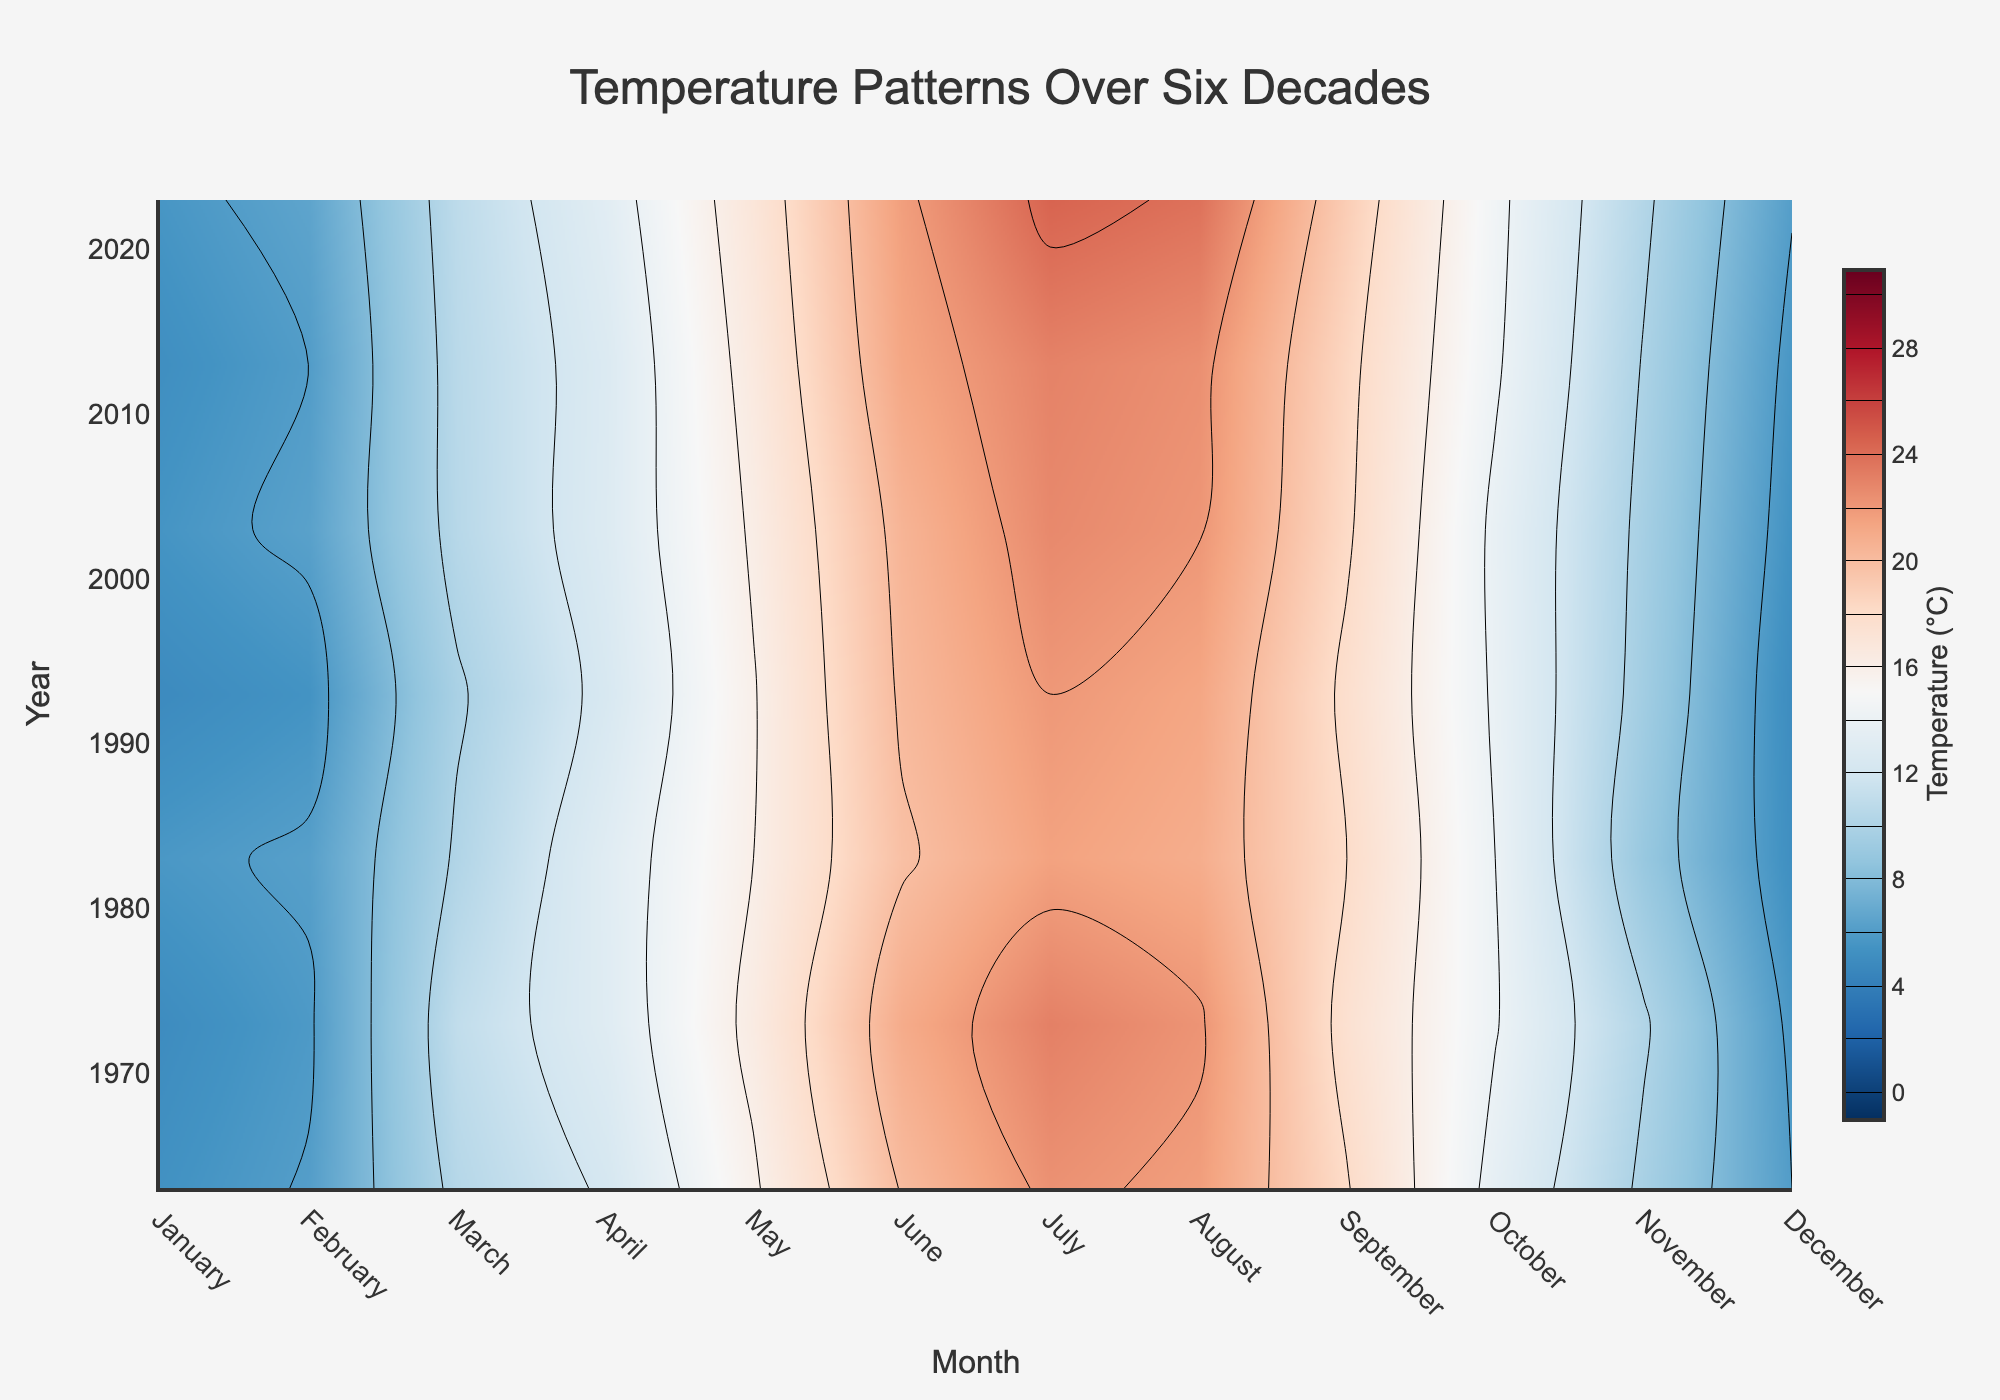What is the overall trend in July temperatures from 1963 to 2023? To answer this, we need to identify the temperature contour values for July over the years. We will observe July temperatures on the y-axis (years) and identify the trends from the contour colors. July temperatures in 1963 and 1973 are around 22-23°C, while in 2023, July temperatures are around 24°C. There is a gradual increase in July temperatures over time.
Answer: Increasing Which year has the highest average temperature in August and what is the temperature? Identify the contour lines for the month of August (x-axis) and look for the peak value. According to the color scale, the highest contour value is seen in August of 2023, which is around 23.8°C.
Answer: 2023, 23.8°C Is there a visible peak in temperature in any particular month over the decades? If so, which month? Examine the contour plot and identify any month where the temperature values repeatedly reach their highest (dark red contours). July often shows the highest peak temperatures compared to other months continuously over the six decades.
Answer: July How do temperatures in January 1963 compare to January 2023? Identify the contour lines for January in both 1963 and 2023. January 1963 has a temperature around 5.3°C, while January 2023 has around 5.6°C. There is a minor increase.
Answer: January 2023 is warmer Which season shows the most considerable increase in average temperatures from 1963 to 2023? Seasons can be divided into Winter (December-February), Spring (March-May), Summer (June-August), and Autumn (September-November). Identify changes in temperature contours for these ranges. Summer (June, July, August) shows notable color changes over time, indicating the most significant increase.
Answer: Summer What general pattern can be observed from the contour colors moving from the bottom of the plot to the top (through the years)? Observe the color changes in the contour plot over the years. Generally, there is a shift from lighter colors to darker colors, indicating an increase in average temperatures over the decades.
Answer: Increasing warmer trend What noticeable change occurs in the temperature pattern during June from 1963 to 2023? Look at the June temperatures in the contour plot over the years. June temperatures start around 20.1°C in 1963 and go up to 21.7°C in 2023, indicating a noticeable increase.
Answer: Noticeable increase 